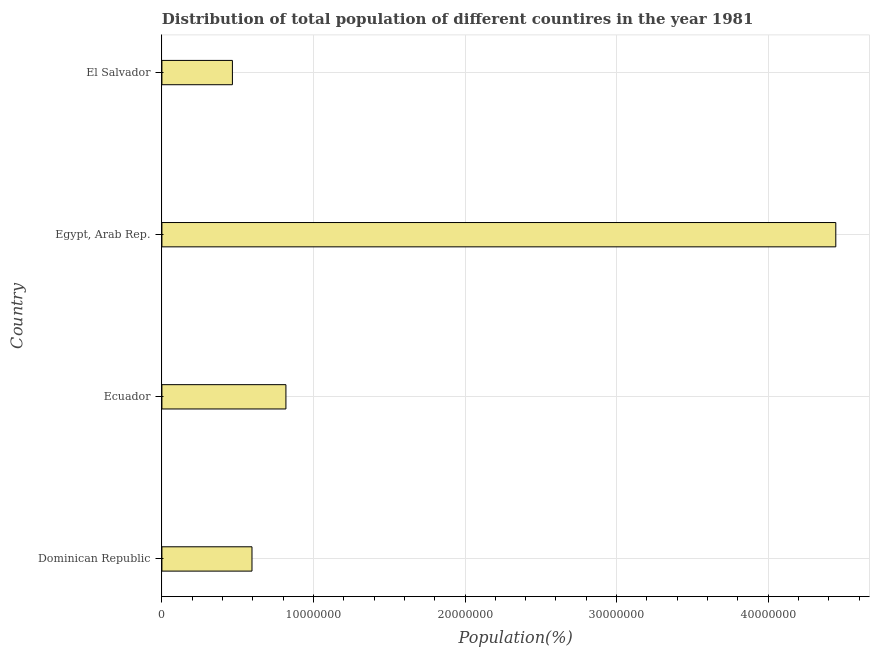Does the graph contain grids?
Provide a succinct answer. Yes. What is the title of the graph?
Your answer should be compact. Distribution of total population of different countires in the year 1981. What is the label or title of the X-axis?
Your response must be concise. Population(%). What is the label or title of the Y-axis?
Make the answer very short. Country. What is the population in El Salvador?
Give a very brief answer. 4.65e+06. Across all countries, what is the maximum population?
Provide a short and direct response. 4.45e+07. Across all countries, what is the minimum population?
Offer a terse response. 4.65e+06. In which country was the population maximum?
Your response must be concise. Egypt, Arab Rep. In which country was the population minimum?
Keep it short and to the point. El Salvador. What is the sum of the population?
Offer a very short reply. 6.32e+07. What is the difference between the population in Ecuador and Egypt, Arab Rep.?
Your answer should be compact. -3.63e+07. What is the average population per country?
Provide a succinct answer. 1.58e+07. What is the median population?
Your answer should be compact. 7.06e+06. In how many countries, is the population greater than 32000000 %?
Offer a terse response. 1. What is the ratio of the population in Dominican Republic to that in El Salvador?
Give a very brief answer. 1.28. What is the difference between the highest and the second highest population?
Your response must be concise. 3.63e+07. What is the difference between the highest and the lowest population?
Make the answer very short. 3.98e+07. In how many countries, is the population greater than the average population taken over all countries?
Your answer should be compact. 1. How many bars are there?
Provide a succinct answer. 4. Are all the bars in the graph horizontal?
Offer a terse response. Yes. How many countries are there in the graph?
Your answer should be very brief. 4. What is the Population(%) in Dominican Republic?
Keep it short and to the point. 5.94e+06. What is the Population(%) in Ecuador?
Offer a terse response. 8.18e+06. What is the Population(%) of Egypt, Arab Rep.?
Make the answer very short. 4.45e+07. What is the Population(%) of El Salvador?
Your response must be concise. 4.65e+06. What is the difference between the Population(%) in Dominican Republic and Ecuador?
Ensure brevity in your answer.  -2.24e+06. What is the difference between the Population(%) in Dominican Republic and Egypt, Arab Rep.?
Offer a terse response. -3.85e+07. What is the difference between the Population(%) in Dominican Republic and El Salvador?
Your answer should be compact. 1.29e+06. What is the difference between the Population(%) in Ecuador and Egypt, Arab Rep.?
Ensure brevity in your answer.  -3.63e+07. What is the difference between the Population(%) in Ecuador and El Salvador?
Give a very brief answer. 3.53e+06. What is the difference between the Population(%) in Egypt, Arab Rep. and El Salvador?
Give a very brief answer. 3.98e+07. What is the ratio of the Population(%) in Dominican Republic to that in Ecuador?
Offer a terse response. 0.73. What is the ratio of the Population(%) in Dominican Republic to that in Egypt, Arab Rep.?
Keep it short and to the point. 0.13. What is the ratio of the Population(%) in Dominican Republic to that in El Salvador?
Offer a terse response. 1.28. What is the ratio of the Population(%) in Ecuador to that in Egypt, Arab Rep.?
Make the answer very short. 0.18. What is the ratio of the Population(%) in Ecuador to that in El Salvador?
Your answer should be compact. 1.76. What is the ratio of the Population(%) in Egypt, Arab Rep. to that in El Salvador?
Provide a short and direct response. 9.56. 